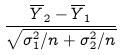<formula> <loc_0><loc_0><loc_500><loc_500>\frac { \overline { Y } _ { 2 } - \overline { Y } _ { 1 } } { \sqrt { \sigma _ { 1 } ^ { 2 } / n + \sigma _ { 2 } ^ { 2 } / n } }</formula> 